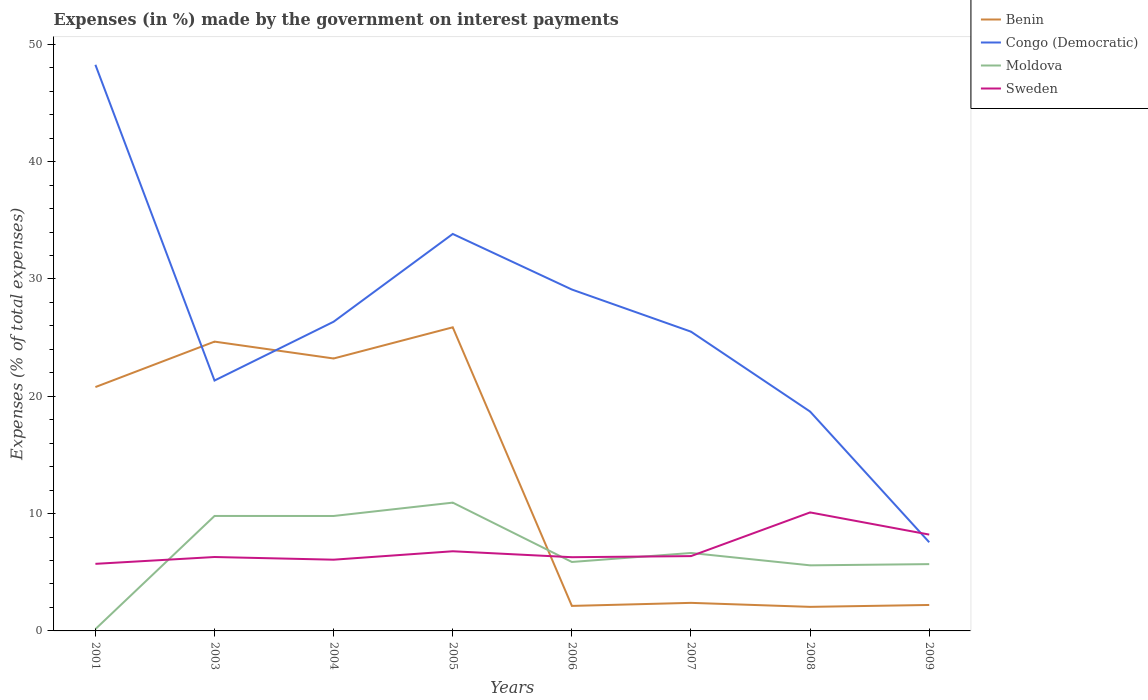How many different coloured lines are there?
Ensure brevity in your answer.  4. Does the line corresponding to Benin intersect with the line corresponding to Sweden?
Provide a short and direct response. Yes. Across all years, what is the maximum percentage of expenses made by the government on interest payments in Benin?
Provide a succinct answer. 2.05. In which year was the percentage of expenses made by the government on interest payments in Congo (Democratic) maximum?
Give a very brief answer. 2009. What is the total percentage of expenses made by the government on interest payments in Moldova in the graph?
Provide a short and direct response. 5.06. What is the difference between the highest and the second highest percentage of expenses made by the government on interest payments in Benin?
Offer a terse response. 23.83. What is the difference between the highest and the lowest percentage of expenses made by the government on interest payments in Moldova?
Ensure brevity in your answer.  3. Is the percentage of expenses made by the government on interest payments in Benin strictly greater than the percentage of expenses made by the government on interest payments in Congo (Democratic) over the years?
Offer a very short reply. No. What is the difference between two consecutive major ticks on the Y-axis?
Offer a terse response. 10. Where does the legend appear in the graph?
Offer a terse response. Top right. What is the title of the graph?
Offer a very short reply. Expenses (in %) made by the government on interest payments. Does "Guyana" appear as one of the legend labels in the graph?
Your answer should be very brief. No. What is the label or title of the X-axis?
Give a very brief answer. Years. What is the label or title of the Y-axis?
Your answer should be very brief. Expenses (% of total expenses). What is the Expenses (% of total expenses) in Benin in 2001?
Ensure brevity in your answer.  20.79. What is the Expenses (% of total expenses) in Congo (Democratic) in 2001?
Offer a terse response. 48.26. What is the Expenses (% of total expenses) in Moldova in 2001?
Your answer should be very brief. 0.16. What is the Expenses (% of total expenses) in Sweden in 2001?
Your answer should be compact. 5.72. What is the Expenses (% of total expenses) in Benin in 2003?
Offer a very short reply. 24.66. What is the Expenses (% of total expenses) in Congo (Democratic) in 2003?
Ensure brevity in your answer.  21.34. What is the Expenses (% of total expenses) of Moldova in 2003?
Your answer should be very brief. 9.8. What is the Expenses (% of total expenses) in Sweden in 2003?
Offer a very short reply. 6.3. What is the Expenses (% of total expenses) of Benin in 2004?
Ensure brevity in your answer.  23.22. What is the Expenses (% of total expenses) in Congo (Democratic) in 2004?
Ensure brevity in your answer.  26.36. What is the Expenses (% of total expenses) in Moldova in 2004?
Provide a short and direct response. 9.8. What is the Expenses (% of total expenses) in Sweden in 2004?
Your response must be concise. 6.07. What is the Expenses (% of total expenses) of Benin in 2005?
Make the answer very short. 25.88. What is the Expenses (% of total expenses) of Congo (Democratic) in 2005?
Your response must be concise. 33.84. What is the Expenses (% of total expenses) of Moldova in 2005?
Provide a short and direct response. 10.94. What is the Expenses (% of total expenses) in Sweden in 2005?
Your answer should be compact. 6.79. What is the Expenses (% of total expenses) in Benin in 2006?
Keep it short and to the point. 2.13. What is the Expenses (% of total expenses) of Congo (Democratic) in 2006?
Provide a short and direct response. 29.1. What is the Expenses (% of total expenses) of Moldova in 2006?
Make the answer very short. 5.88. What is the Expenses (% of total expenses) of Sweden in 2006?
Offer a terse response. 6.28. What is the Expenses (% of total expenses) of Benin in 2007?
Ensure brevity in your answer.  2.39. What is the Expenses (% of total expenses) of Congo (Democratic) in 2007?
Give a very brief answer. 25.51. What is the Expenses (% of total expenses) of Moldova in 2007?
Offer a very short reply. 6.64. What is the Expenses (% of total expenses) of Sweden in 2007?
Offer a terse response. 6.38. What is the Expenses (% of total expenses) in Benin in 2008?
Give a very brief answer. 2.05. What is the Expenses (% of total expenses) in Congo (Democratic) in 2008?
Provide a succinct answer. 18.7. What is the Expenses (% of total expenses) in Moldova in 2008?
Ensure brevity in your answer.  5.59. What is the Expenses (% of total expenses) of Sweden in 2008?
Offer a very short reply. 10.1. What is the Expenses (% of total expenses) of Benin in 2009?
Your response must be concise. 2.21. What is the Expenses (% of total expenses) in Congo (Democratic) in 2009?
Offer a terse response. 7.56. What is the Expenses (% of total expenses) of Moldova in 2009?
Offer a very short reply. 5.69. What is the Expenses (% of total expenses) of Sweden in 2009?
Provide a succinct answer. 8.21. Across all years, what is the maximum Expenses (% of total expenses) of Benin?
Your answer should be very brief. 25.88. Across all years, what is the maximum Expenses (% of total expenses) of Congo (Democratic)?
Provide a succinct answer. 48.26. Across all years, what is the maximum Expenses (% of total expenses) of Moldova?
Make the answer very short. 10.94. Across all years, what is the maximum Expenses (% of total expenses) in Sweden?
Keep it short and to the point. 10.1. Across all years, what is the minimum Expenses (% of total expenses) in Benin?
Make the answer very short. 2.05. Across all years, what is the minimum Expenses (% of total expenses) in Congo (Democratic)?
Your answer should be compact. 7.56. Across all years, what is the minimum Expenses (% of total expenses) in Moldova?
Keep it short and to the point. 0.16. Across all years, what is the minimum Expenses (% of total expenses) in Sweden?
Your answer should be compact. 5.72. What is the total Expenses (% of total expenses) of Benin in the graph?
Provide a succinct answer. 103.34. What is the total Expenses (% of total expenses) in Congo (Democratic) in the graph?
Your answer should be very brief. 210.66. What is the total Expenses (% of total expenses) of Moldova in the graph?
Provide a succinct answer. 54.49. What is the total Expenses (% of total expenses) of Sweden in the graph?
Your response must be concise. 55.85. What is the difference between the Expenses (% of total expenses) in Benin in 2001 and that in 2003?
Ensure brevity in your answer.  -3.87. What is the difference between the Expenses (% of total expenses) of Congo (Democratic) in 2001 and that in 2003?
Your answer should be very brief. 26.91. What is the difference between the Expenses (% of total expenses) of Moldova in 2001 and that in 2003?
Provide a short and direct response. -9.64. What is the difference between the Expenses (% of total expenses) of Sweden in 2001 and that in 2003?
Make the answer very short. -0.58. What is the difference between the Expenses (% of total expenses) in Benin in 2001 and that in 2004?
Ensure brevity in your answer.  -2.44. What is the difference between the Expenses (% of total expenses) in Congo (Democratic) in 2001 and that in 2004?
Make the answer very short. 21.9. What is the difference between the Expenses (% of total expenses) of Moldova in 2001 and that in 2004?
Offer a very short reply. -9.64. What is the difference between the Expenses (% of total expenses) in Sweden in 2001 and that in 2004?
Your response must be concise. -0.35. What is the difference between the Expenses (% of total expenses) of Benin in 2001 and that in 2005?
Your response must be concise. -5.09. What is the difference between the Expenses (% of total expenses) of Congo (Democratic) in 2001 and that in 2005?
Your answer should be very brief. 14.42. What is the difference between the Expenses (% of total expenses) in Moldova in 2001 and that in 2005?
Provide a succinct answer. -10.78. What is the difference between the Expenses (% of total expenses) in Sweden in 2001 and that in 2005?
Give a very brief answer. -1.07. What is the difference between the Expenses (% of total expenses) in Benin in 2001 and that in 2006?
Ensure brevity in your answer.  18.65. What is the difference between the Expenses (% of total expenses) in Congo (Democratic) in 2001 and that in 2006?
Your answer should be compact. 19.16. What is the difference between the Expenses (% of total expenses) in Moldova in 2001 and that in 2006?
Provide a short and direct response. -5.72. What is the difference between the Expenses (% of total expenses) of Sweden in 2001 and that in 2006?
Offer a very short reply. -0.57. What is the difference between the Expenses (% of total expenses) of Benin in 2001 and that in 2007?
Keep it short and to the point. 18.4. What is the difference between the Expenses (% of total expenses) in Congo (Democratic) in 2001 and that in 2007?
Make the answer very short. 22.75. What is the difference between the Expenses (% of total expenses) of Moldova in 2001 and that in 2007?
Provide a short and direct response. -6.49. What is the difference between the Expenses (% of total expenses) of Sweden in 2001 and that in 2007?
Your response must be concise. -0.66. What is the difference between the Expenses (% of total expenses) in Benin in 2001 and that in 2008?
Your response must be concise. 18.74. What is the difference between the Expenses (% of total expenses) in Congo (Democratic) in 2001 and that in 2008?
Keep it short and to the point. 29.56. What is the difference between the Expenses (% of total expenses) in Moldova in 2001 and that in 2008?
Keep it short and to the point. -5.43. What is the difference between the Expenses (% of total expenses) of Sweden in 2001 and that in 2008?
Your answer should be compact. -4.38. What is the difference between the Expenses (% of total expenses) of Benin in 2001 and that in 2009?
Your answer should be compact. 18.57. What is the difference between the Expenses (% of total expenses) of Congo (Democratic) in 2001 and that in 2009?
Your response must be concise. 40.7. What is the difference between the Expenses (% of total expenses) in Moldova in 2001 and that in 2009?
Your answer should be compact. -5.54. What is the difference between the Expenses (% of total expenses) of Sweden in 2001 and that in 2009?
Offer a terse response. -2.49. What is the difference between the Expenses (% of total expenses) of Benin in 2003 and that in 2004?
Give a very brief answer. 1.44. What is the difference between the Expenses (% of total expenses) in Congo (Democratic) in 2003 and that in 2004?
Provide a short and direct response. -5.01. What is the difference between the Expenses (% of total expenses) of Moldova in 2003 and that in 2004?
Your response must be concise. 0. What is the difference between the Expenses (% of total expenses) in Sweden in 2003 and that in 2004?
Your answer should be very brief. 0.23. What is the difference between the Expenses (% of total expenses) of Benin in 2003 and that in 2005?
Make the answer very short. -1.22. What is the difference between the Expenses (% of total expenses) of Congo (Democratic) in 2003 and that in 2005?
Provide a succinct answer. -12.5. What is the difference between the Expenses (% of total expenses) of Moldova in 2003 and that in 2005?
Your answer should be compact. -1.14. What is the difference between the Expenses (% of total expenses) of Sweden in 2003 and that in 2005?
Keep it short and to the point. -0.49. What is the difference between the Expenses (% of total expenses) of Benin in 2003 and that in 2006?
Ensure brevity in your answer.  22.53. What is the difference between the Expenses (% of total expenses) of Congo (Democratic) in 2003 and that in 2006?
Offer a terse response. -7.76. What is the difference between the Expenses (% of total expenses) in Moldova in 2003 and that in 2006?
Your response must be concise. 3.92. What is the difference between the Expenses (% of total expenses) in Sweden in 2003 and that in 2006?
Give a very brief answer. 0.02. What is the difference between the Expenses (% of total expenses) in Benin in 2003 and that in 2007?
Your response must be concise. 22.27. What is the difference between the Expenses (% of total expenses) in Congo (Democratic) in 2003 and that in 2007?
Provide a short and direct response. -4.17. What is the difference between the Expenses (% of total expenses) of Moldova in 2003 and that in 2007?
Provide a succinct answer. 3.16. What is the difference between the Expenses (% of total expenses) in Sweden in 2003 and that in 2007?
Offer a very short reply. -0.08. What is the difference between the Expenses (% of total expenses) in Benin in 2003 and that in 2008?
Give a very brief answer. 22.61. What is the difference between the Expenses (% of total expenses) in Congo (Democratic) in 2003 and that in 2008?
Give a very brief answer. 2.65. What is the difference between the Expenses (% of total expenses) in Moldova in 2003 and that in 2008?
Keep it short and to the point. 4.21. What is the difference between the Expenses (% of total expenses) of Sweden in 2003 and that in 2008?
Offer a very short reply. -3.8. What is the difference between the Expenses (% of total expenses) of Benin in 2003 and that in 2009?
Ensure brevity in your answer.  22.45. What is the difference between the Expenses (% of total expenses) in Congo (Democratic) in 2003 and that in 2009?
Make the answer very short. 13.79. What is the difference between the Expenses (% of total expenses) in Moldova in 2003 and that in 2009?
Keep it short and to the point. 4.11. What is the difference between the Expenses (% of total expenses) in Sweden in 2003 and that in 2009?
Your answer should be very brief. -1.91. What is the difference between the Expenses (% of total expenses) in Benin in 2004 and that in 2005?
Offer a very short reply. -2.66. What is the difference between the Expenses (% of total expenses) of Congo (Democratic) in 2004 and that in 2005?
Make the answer very short. -7.48. What is the difference between the Expenses (% of total expenses) in Moldova in 2004 and that in 2005?
Provide a short and direct response. -1.14. What is the difference between the Expenses (% of total expenses) in Sweden in 2004 and that in 2005?
Your response must be concise. -0.72. What is the difference between the Expenses (% of total expenses) of Benin in 2004 and that in 2006?
Offer a terse response. 21.09. What is the difference between the Expenses (% of total expenses) in Congo (Democratic) in 2004 and that in 2006?
Provide a succinct answer. -2.74. What is the difference between the Expenses (% of total expenses) of Moldova in 2004 and that in 2006?
Provide a short and direct response. 3.92. What is the difference between the Expenses (% of total expenses) of Sweden in 2004 and that in 2006?
Your answer should be very brief. -0.21. What is the difference between the Expenses (% of total expenses) in Benin in 2004 and that in 2007?
Offer a terse response. 20.83. What is the difference between the Expenses (% of total expenses) in Congo (Democratic) in 2004 and that in 2007?
Provide a short and direct response. 0.85. What is the difference between the Expenses (% of total expenses) of Moldova in 2004 and that in 2007?
Give a very brief answer. 3.15. What is the difference between the Expenses (% of total expenses) of Sweden in 2004 and that in 2007?
Keep it short and to the point. -0.31. What is the difference between the Expenses (% of total expenses) in Benin in 2004 and that in 2008?
Provide a succinct answer. 21.17. What is the difference between the Expenses (% of total expenses) in Congo (Democratic) in 2004 and that in 2008?
Offer a terse response. 7.66. What is the difference between the Expenses (% of total expenses) in Moldova in 2004 and that in 2008?
Offer a terse response. 4.21. What is the difference between the Expenses (% of total expenses) of Sweden in 2004 and that in 2008?
Ensure brevity in your answer.  -4.03. What is the difference between the Expenses (% of total expenses) of Benin in 2004 and that in 2009?
Give a very brief answer. 21.01. What is the difference between the Expenses (% of total expenses) in Congo (Democratic) in 2004 and that in 2009?
Provide a short and direct response. 18.8. What is the difference between the Expenses (% of total expenses) of Moldova in 2004 and that in 2009?
Offer a terse response. 4.1. What is the difference between the Expenses (% of total expenses) of Sweden in 2004 and that in 2009?
Offer a terse response. -2.14. What is the difference between the Expenses (% of total expenses) in Benin in 2005 and that in 2006?
Your response must be concise. 23.75. What is the difference between the Expenses (% of total expenses) of Congo (Democratic) in 2005 and that in 2006?
Keep it short and to the point. 4.74. What is the difference between the Expenses (% of total expenses) of Moldova in 2005 and that in 2006?
Your response must be concise. 5.06. What is the difference between the Expenses (% of total expenses) of Sweden in 2005 and that in 2006?
Provide a short and direct response. 0.51. What is the difference between the Expenses (% of total expenses) in Benin in 2005 and that in 2007?
Offer a terse response. 23.49. What is the difference between the Expenses (% of total expenses) in Congo (Democratic) in 2005 and that in 2007?
Your answer should be compact. 8.33. What is the difference between the Expenses (% of total expenses) in Moldova in 2005 and that in 2007?
Provide a short and direct response. 4.29. What is the difference between the Expenses (% of total expenses) of Sweden in 2005 and that in 2007?
Ensure brevity in your answer.  0.41. What is the difference between the Expenses (% of total expenses) of Benin in 2005 and that in 2008?
Provide a succinct answer. 23.83. What is the difference between the Expenses (% of total expenses) in Congo (Democratic) in 2005 and that in 2008?
Give a very brief answer. 15.14. What is the difference between the Expenses (% of total expenses) in Moldova in 2005 and that in 2008?
Your answer should be compact. 5.35. What is the difference between the Expenses (% of total expenses) in Sweden in 2005 and that in 2008?
Provide a short and direct response. -3.31. What is the difference between the Expenses (% of total expenses) of Benin in 2005 and that in 2009?
Ensure brevity in your answer.  23.67. What is the difference between the Expenses (% of total expenses) in Congo (Democratic) in 2005 and that in 2009?
Offer a very short reply. 26.28. What is the difference between the Expenses (% of total expenses) in Moldova in 2005 and that in 2009?
Give a very brief answer. 5.24. What is the difference between the Expenses (% of total expenses) of Sweden in 2005 and that in 2009?
Offer a terse response. -1.42. What is the difference between the Expenses (% of total expenses) in Benin in 2006 and that in 2007?
Ensure brevity in your answer.  -0.26. What is the difference between the Expenses (% of total expenses) in Congo (Democratic) in 2006 and that in 2007?
Give a very brief answer. 3.59. What is the difference between the Expenses (% of total expenses) of Moldova in 2006 and that in 2007?
Your answer should be compact. -0.77. What is the difference between the Expenses (% of total expenses) in Sweden in 2006 and that in 2007?
Offer a very short reply. -0.09. What is the difference between the Expenses (% of total expenses) of Benin in 2006 and that in 2008?
Ensure brevity in your answer.  0.08. What is the difference between the Expenses (% of total expenses) of Congo (Democratic) in 2006 and that in 2008?
Keep it short and to the point. 10.4. What is the difference between the Expenses (% of total expenses) of Moldova in 2006 and that in 2008?
Provide a succinct answer. 0.29. What is the difference between the Expenses (% of total expenses) in Sweden in 2006 and that in 2008?
Your answer should be very brief. -3.82. What is the difference between the Expenses (% of total expenses) in Benin in 2006 and that in 2009?
Provide a succinct answer. -0.08. What is the difference between the Expenses (% of total expenses) in Congo (Democratic) in 2006 and that in 2009?
Offer a terse response. 21.54. What is the difference between the Expenses (% of total expenses) in Moldova in 2006 and that in 2009?
Give a very brief answer. 0.18. What is the difference between the Expenses (% of total expenses) of Sweden in 2006 and that in 2009?
Provide a succinct answer. -1.93. What is the difference between the Expenses (% of total expenses) in Benin in 2007 and that in 2008?
Keep it short and to the point. 0.34. What is the difference between the Expenses (% of total expenses) of Congo (Democratic) in 2007 and that in 2008?
Provide a succinct answer. 6.81. What is the difference between the Expenses (% of total expenses) of Moldova in 2007 and that in 2008?
Your answer should be very brief. 1.05. What is the difference between the Expenses (% of total expenses) in Sweden in 2007 and that in 2008?
Your answer should be very brief. -3.72. What is the difference between the Expenses (% of total expenses) in Benin in 2007 and that in 2009?
Make the answer very short. 0.18. What is the difference between the Expenses (% of total expenses) of Congo (Democratic) in 2007 and that in 2009?
Offer a terse response. 17.95. What is the difference between the Expenses (% of total expenses) of Moldova in 2007 and that in 2009?
Provide a succinct answer. 0.95. What is the difference between the Expenses (% of total expenses) of Sweden in 2007 and that in 2009?
Offer a very short reply. -1.83. What is the difference between the Expenses (% of total expenses) in Benin in 2008 and that in 2009?
Give a very brief answer. -0.16. What is the difference between the Expenses (% of total expenses) of Congo (Democratic) in 2008 and that in 2009?
Ensure brevity in your answer.  11.14. What is the difference between the Expenses (% of total expenses) in Moldova in 2008 and that in 2009?
Make the answer very short. -0.1. What is the difference between the Expenses (% of total expenses) in Sweden in 2008 and that in 2009?
Provide a succinct answer. 1.89. What is the difference between the Expenses (% of total expenses) of Benin in 2001 and the Expenses (% of total expenses) of Congo (Democratic) in 2003?
Make the answer very short. -0.56. What is the difference between the Expenses (% of total expenses) in Benin in 2001 and the Expenses (% of total expenses) in Moldova in 2003?
Your answer should be very brief. 10.99. What is the difference between the Expenses (% of total expenses) of Benin in 2001 and the Expenses (% of total expenses) of Sweden in 2003?
Offer a very short reply. 14.49. What is the difference between the Expenses (% of total expenses) in Congo (Democratic) in 2001 and the Expenses (% of total expenses) in Moldova in 2003?
Ensure brevity in your answer.  38.46. What is the difference between the Expenses (% of total expenses) of Congo (Democratic) in 2001 and the Expenses (% of total expenses) of Sweden in 2003?
Make the answer very short. 41.96. What is the difference between the Expenses (% of total expenses) of Moldova in 2001 and the Expenses (% of total expenses) of Sweden in 2003?
Your answer should be very brief. -6.14. What is the difference between the Expenses (% of total expenses) in Benin in 2001 and the Expenses (% of total expenses) in Congo (Democratic) in 2004?
Offer a terse response. -5.57. What is the difference between the Expenses (% of total expenses) in Benin in 2001 and the Expenses (% of total expenses) in Moldova in 2004?
Offer a very short reply. 10.99. What is the difference between the Expenses (% of total expenses) in Benin in 2001 and the Expenses (% of total expenses) in Sweden in 2004?
Your answer should be compact. 14.72. What is the difference between the Expenses (% of total expenses) in Congo (Democratic) in 2001 and the Expenses (% of total expenses) in Moldova in 2004?
Your answer should be very brief. 38.46. What is the difference between the Expenses (% of total expenses) in Congo (Democratic) in 2001 and the Expenses (% of total expenses) in Sweden in 2004?
Provide a succinct answer. 42.19. What is the difference between the Expenses (% of total expenses) in Moldova in 2001 and the Expenses (% of total expenses) in Sweden in 2004?
Your answer should be very brief. -5.92. What is the difference between the Expenses (% of total expenses) of Benin in 2001 and the Expenses (% of total expenses) of Congo (Democratic) in 2005?
Give a very brief answer. -13.05. What is the difference between the Expenses (% of total expenses) in Benin in 2001 and the Expenses (% of total expenses) in Moldova in 2005?
Provide a short and direct response. 9.85. What is the difference between the Expenses (% of total expenses) of Benin in 2001 and the Expenses (% of total expenses) of Sweden in 2005?
Make the answer very short. 14. What is the difference between the Expenses (% of total expenses) in Congo (Democratic) in 2001 and the Expenses (% of total expenses) in Moldova in 2005?
Provide a short and direct response. 37.32. What is the difference between the Expenses (% of total expenses) of Congo (Democratic) in 2001 and the Expenses (% of total expenses) of Sweden in 2005?
Make the answer very short. 41.47. What is the difference between the Expenses (% of total expenses) of Moldova in 2001 and the Expenses (% of total expenses) of Sweden in 2005?
Offer a terse response. -6.63. What is the difference between the Expenses (% of total expenses) of Benin in 2001 and the Expenses (% of total expenses) of Congo (Democratic) in 2006?
Provide a short and direct response. -8.31. What is the difference between the Expenses (% of total expenses) of Benin in 2001 and the Expenses (% of total expenses) of Moldova in 2006?
Keep it short and to the point. 14.91. What is the difference between the Expenses (% of total expenses) of Benin in 2001 and the Expenses (% of total expenses) of Sweden in 2006?
Provide a succinct answer. 14.5. What is the difference between the Expenses (% of total expenses) of Congo (Democratic) in 2001 and the Expenses (% of total expenses) of Moldova in 2006?
Your response must be concise. 42.38. What is the difference between the Expenses (% of total expenses) in Congo (Democratic) in 2001 and the Expenses (% of total expenses) in Sweden in 2006?
Your response must be concise. 41.97. What is the difference between the Expenses (% of total expenses) of Moldova in 2001 and the Expenses (% of total expenses) of Sweden in 2006?
Ensure brevity in your answer.  -6.13. What is the difference between the Expenses (% of total expenses) of Benin in 2001 and the Expenses (% of total expenses) of Congo (Democratic) in 2007?
Offer a very short reply. -4.72. What is the difference between the Expenses (% of total expenses) in Benin in 2001 and the Expenses (% of total expenses) in Moldova in 2007?
Your answer should be compact. 14.14. What is the difference between the Expenses (% of total expenses) in Benin in 2001 and the Expenses (% of total expenses) in Sweden in 2007?
Your answer should be compact. 14.41. What is the difference between the Expenses (% of total expenses) of Congo (Democratic) in 2001 and the Expenses (% of total expenses) of Moldova in 2007?
Provide a short and direct response. 41.61. What is the difference between the Expenses (% of total expenses) in Congo (Democratic) in 2001 and the Expenses (% of total expenses) in Sweden in 2007?
Offer a terse response. 41.88. What is the difference between the Expenses (% of total expenses) in Moldova in 2001 and the Expenses (% of total expenses) in Sweden in 2007?
Give a very brief answer. -6.22. What is the difference between the Expenses (% of total expenses) in Benin in 2001 and the Expenses (% of total expenses) in Congo (Democratic) in 2008?
Keep it short and to the point. 2.09. What is the difference between the Expenses (% of total expenses) of Benin in 2001 and the Expenses (% of total expenses) of Moldova in 2008?
Ensure brevity in your answer.  15.2. What is the difference between the Expenses (% of total expenses) in Benin in 2001 and the Expenses (% of total expenses) in Sweden in 2008?
Provide a succinct answer. 10.69. What is the difference between the Expenses (% of total expenses) of Congo (Democratic) in 2001 and the Expenses (% of total expenses) of Moldova in 2008?
Give a very brief answer. 42.67. What is the difference between the Expenses (% of total expenses) in Congo (Democratic) in 2001 and the Expenses (% of total expenses) in Sweden in 2008?
Offer a terse response. 38.16. What is the difference between the Expenses (% of total expenses) in Moldova in 2001 and the Expenses (% of total expenses) in Sweden in 2008?
Offer a very short reply. -9.95. What is the difference between the Expenses (% of total expenses) in Benin in 2001 and the Expenses (% of total expenses) in Congo (Democratic) in 2009?
Offer a terse response. 13.23. What is the difference between the Expenses (% of total expenses) in Benin in 2001 and the Expenses (% of total expenses) in Moldova in 2009?
Provide a succinct answer. 15.09. What is the difference between the Expenses (% of total expenses) of Benin in 2001 and the Expenses (% of total expenses) of Sweden in 2009?
Ensure brevity in your answer.  12.58. What is the difference between the Expenses (% of total expenses) of Congo (Democratic) in 2001 and the Expenses (% of total expenses) of Moldova in 2009?
Your answer should be compact. 42.56. What is the difference between the Expenses (% of total expenses) of Congo (Democratic) in 2001 and the Expenses (% of total expenses) of Sweden in 2009?
Make the answer very short. 40.05. What is the difference between the Expenses (% of total expenses) in Moldova in 2001 and the Expenses (% of total expenses) in Sweden in 2009?
Your answer should be compact. -8.06. What is the difference between the Expenses (% of total expenses) in Benin in 2003 and the Expenses (% of total expenses) in Congo (Democratic) in 2004?
Make the answer very short. -1.7. What is the difference between the Expenses (% of total expenses) of Benin in 2003 and the Expenses (% of total expenses) of Moldova in 2004?
Your answer should be very brief. 14.86. What is the difference between the Expenses (% of total expenses) of Benin in 2003 and the Expenses (% of total expenses) of Sweden in 2004?
Make the answer very short. 18.59. What is the difference between the Expenses (% of total expenses) of Congo (Democratic) in 2003 and the Expenses (% of total expenses) of Moldova in 2004?
Ensure brevity in your answer.  11.54. What is the difference between the Expenses (% of total expenses) in Congo (Democratic) in 2003 and the Expenses (% of total expenses) in Sweden in 2004?
Keep it short and to the point. 15.27. What is the difference between the Expenses (% of total expenses) in Moldova in 2003 and the Expenses (% of total expenses) in Sweden in 2004?
Provide a short and direct response. 3.73. What is the difference between the Expenses (% of total expenses) in Benin in 2003 and the Expenses (% of total expenses) in Congo (Democratic) in 2005?
Ensure brevity in your answer.  -9.18. What is the difference between the Expenses (% of total expenses) of Benin in 2003 and the Expenses (% of total expenses) of Moldova in 2005?
Your answer should be compact. 13.72. What is the difference between the Expenses (% of total expenses) of Benin in 2003 and the Expenses (% of total expenses) of Sweden in 2005?
Your answer should be very brief. 17.87. What is the difference between the Expenses (% of total expenses) of Congo (Democratic) in 2003 and the Expenses (% of total expenses) of Moldova in 2005?
Your answer should be very brief. 10.41. What is the difference between the Expenses (% of total expenses) in Congo (Democratic) in 2003 and the Expenses (% of total expenses) in Sweden in 2005?
Offer a terse response. 14.55. What is the difference between the Expenses (% of total expenses) of Moldova in 2003 and the Expenses (% of total expenses) of Sweden in 2005?
Make the answer very short. 3.01. What is the difference between the Expenses (% of total expenses) of Benin in 2003 and the Expenses (% of total expenses) of Congo (Democratic) in 2006?
Give a very brief answer. -4.44. What is the difference between the Expenses (% of total expenses) of Benin in 2003 and the Expenses (% of total expenses) of Moldova in 2006?
Your answer should be very brief. 18.78. What is the difference between the Expenses (% of total expenses) of Benin in 2003 and the Expenses (% of total expenses) of Sweden in 2006?
Offer a terse response. 18.38. What is the difference between the Expenses (% of total expenses) of Congo (Democratic) in 2003 and the Expenses (% of total expenses) of Moldova in 2006?
Keep it short and to the point. 15.47. What is the difference between the Expenses (% of total expenses) of Congo (Democratic) in 2003 and the Expenses (% of total expenses) of Sweden in 2006?
Provide a succinct answer. 15.06. What is the difference between the Expenses (% of total expenses) in Moldova in 2003 and the Expenses (% of total expenses) in Sweden in 2006?
Ensure brevity in your answer.  3.52. What is the difference between the Expenses (% of total expenses) in Benin in 2003 and the Expenses (% of total expenses) in Congo (Democratic) in 2007?
Keep it short and to the point. -0.85. What is the difference between the Expenses (% of total expenses) in Benin in 2003 and the Expenses (% of total expenses) in Moldova in 2007?
Give a very brief answer. 18.02. What is the difference between the Expenses (% of total expenses) of Benin in 2003 and the Expenses (% of total expenses) of Sweden in 2007?
Ensure brevity in your answer.  18.28. What is the difference between the Expenses (% of total expenses) of Congo (Democratic) in 2003 and the Expenses (% of total expenses) of Moldova in 2007?
Provide a succinct answer. 14.7. What is the difference between the Expenses (% of total expenses) of Congo (Democratic) in 2003 and the Expenses (% of total expenses) of Sweden in 2007?
Ensure brevity in your answer.  14.97. What is the difference between the Expenses (% of total expenses) of Moldova in 2003 and the Expenses (% of total expenses) of Sweden in 2007?
Your answer should be very brief. 3.42. What is the difference between the Expenses (% of total expenses) of Benin in 2003 and the Expenses (% of total expenses) of Congo (Democratic) in 2008?
Provide a succinct answer. 5.96. What is the difference between the Expenses (% of total expenses) of Benin in 2003 and the Expenses (% of total expenses) of Moldova in 2008?
Your answer should be very brief. 19.07. What is the difference between the Expenses (% of total expenses) of Benin in 2003 and the Expenses (% of total expenses) of Sweden in 2008?
Provide a short and direct response. 14.56. What is the difference between the Expenses (% of total expenses) in Congo (Democratic) in 2003 and the Expenses (% of total expenses) in Moldova in 2008?
Your answer should be very brief. 15.75. What is the difference between the Expenses (% of total expenses) in Congo (Democratic) in 2003 and the Expenses (% of total expenses) in Sweden in 2008?
Your answer should be very brief. 11.24. What is the difference between the Expenses (% of total expenses) in Moldova in 2003 and the Expenses (% of total expenses) in Sweden in 2008?
Offer a terse response. -0.3. What is the difference between the Expenses (% of total expenses) in Benin in 2003 and the Expenses (% of total expenses) in Congo (Democratic) in 2009?
Your answer should be very brief. 17.1. What is the difference between the Expenses (% of total expenses) in Benin in 2003 and the Expenses (% of total expenses) in Moldova in 2009?
Offer a very short reply. 18.97. What is the difference between the Expenses (% of total expenses) in Benin in 2003 and the Expenses (% of total expenses) in Sweden in 2009?
Make the answer very short. 16.45. What is the difference between the Expenses (% of total expenses) in Congo (Democratic) in 2003 and the Expenses (% of total expenses) in Moldova in 2009?
Your response must be concise. 15.65. What is the difference between the Expenses (% of total expenses) of Congo (Democratic) in 2003 and the Expenses (% of total expenses) of Sweden in 2009?
Keep it short and to the point. 13.13. What is the difference between the Expenses (% of total expenses) in Moldova in 2003 and the Expenses (% of total expenses) in Sweden in 2009?
Make the answer very short. 1.59. What is the difference between the Expenses (% of total expenses) in Benin in 2004 and the Expenses (% of total expenses) in Congo (Democratic) in 2005?
Your answer should be very brief. -10.62. What is the difference between the Expenses (% of total expenses) of Benin in 2004 and the Expenses (% of total expenses) of Moldova in 2005?
Your answer should be very brief. 12.29. What is the difference between the Expenses (% of total expenses) of Benin in 2004 and the Expenses (% of total expenses) of Sweden in 2005?
Offer a very short reply. 16.43. What is the difference between the Expenses (% of total expenses) of Congo (Democratic) in 2004 and the Expenses (% of total expenses) of Moldova in 2005?
Offer a very short reply. 15.42. What is the difference between the Expenses (% of total expenses) of Congo (Democratic) in 2004 and the Expenses (% of total expenses) of Sweden in 2005?
Provide a succinct answer. 19.57. What is the difference between the Expenses (% of total expenses) in Moldova in 2004 and the Expenses (% of total expenses) in Sweden in 2005?
Ensure brevity in your answer.  3.01. What is the difference between the Expenses (% of total expenses) of Benin in 2004 and the Expenses (% of total expenses) of Congo (Democratic) in 2006?
Your answer should be compact. -5.88. What is the difference between the Expenses (% of total expenses) in Benin in 2004 and the Expenses (% of total expenses) in Moldova in 2006?
Provide a succinct answer. 17.34. What is the difference between the Expenses (% of total expenses) of Benin in 2004 and the Expenses (% of total expenses) of Sweden in 2006?
Offer a terse response. 16.94. What is the difference between the Expenses (% of total expenses) in Congo (Democratic) in 2004 and the Expenses (% of total expenses) in Moldova in 2006?
Provide a short and direct response. 20.48. What is the difference between the Expenses (% of total expenses) of Congo (Democratic) in 2004 and the Expenses (% of total expenses) of Sweden in 2006?
Offer a very short reply. 20.07. What is the difference between the Expenses (% of total expenses) of Moldova in 2004 and the Expenses (% of total expenses) of Sweden in 2006?
Make the answer very short. 3.51. What is the difference between the Expenses (% of total expenses) in Benin in 2004 and the Expenses (% of total expenses) in Congo (Democratic) in 2007?
Offer a very short reply. -2.29. What is the difference between the Expenses (% of total expenses) in Benin in 2004 and the Expenses (% of total expenses) in Moldova in 2007?
Your answer should be very brief. 16.58. What is the difference between the Expenses (% of total expenses) of Benin in 2004 and the Expenses (% of total expenses) of Sweden in 2007?
Your answer should be very brief. 16.85. What is the difference between the Expenses (% of total expenses) of Congo (Democratic) in 2004 and the Expenses (% of total expenses) of Moldova in 2007?
Make the answer very short. 19.71. What is the difference between the Expenses (% of total expenses) of Congo (Democratic) in 2004 and the Expenses (% of total expenses) of Sweden in 2007?
Ensure brevity in your answer.  19.98. What is the difference between the Expenses (% of total expenses) in Moldova in 2004 and the Expenses (% of total expenses) in Sweden in 2007?
Offer a terse response. 3.42. What is the difference between the Expenses (% of total expenses) of Benin in 2004 and the Expenses (% of total expenses) of Congo (Democratic) in 2008?
Your response must be concise. 4.53. What is the difference between the Expenses (% of total expenses) in Benin in 2004 and the Expenses (% of total expenses) in Moldova in 2008?
Keep it short and to the point. 17.63. What is the difference between the Expenses (% of total expenses) of Benin in 2004 and the Expenses (% of total expenses) of Sweden in 2008?
Provide a short and direct response. 13.12. What is the difference between the Expenses (% of total expenses) in Congo (Democratic) in 2004 and the Expenses (% of total expenses) in Moldova in 2008?
Provide a short and direct response. 20.77. What is the difference between the Expenses (% of total expenses) in Congo (Democratic) in 2004 and the Expenses (% of total expenses) in Sweden in 2008?
Your answer should be very brief. 16.26. What is the difference between the Expenses (% of total expenses) in Moldova in 2004 and the Expenses (% of total expenses) in Sweden in 2008?
Your answer should be very brief. -0.3. What is the difference between the Expenses (% of total expenses) in Benin in 2004 and the Expenses (% of total expenses) in Congo (Democratic) in 2009?
Make the answer very short. 15.67. What is the difference between the Expenses (% of total expenses) of Benin in 2004 and the Expenses (% of total expenses) of Moldova in 2009?
Your answer should be very brief. 17.53. What is the difference between the Expenses (% of total expenses) in Benin in 2004 and the Expenses (% of total expenses) in Sweden in 2009?
Make the answer very short. 15.01. What is the difference between the Expenses (% of total expenses) of Congo (Democratic) in 2004 and the Expenses (% of total expenses) of Moldova in 2009?
Keep it short and to the point. 20.66. What is the difference between the Expenses (% of total expenses) in Congo (Democratic) in 2004 and the Expenses (% of total expenses) in Sweden in 2009?
Provide a short and direct response. 18.15. What is the difference between the Expenses (% of total expenses) in Moldova in 2004 and the Expenses (% of total expenses) in Sweden in 2009?
Your answer should be very brief. 1.59. What is the difference between the Expenses (% of total expenses) in Benin in 2005 and the Expenses (% of total expenses) in Congo (Democratic) in 2006?
Offer a very short reply. -3.22. What is the difference between the Expenses (% of total expenses) of Benin in 2005 and the Expenses (% of total expenses) of Moldova in 2006?
Provide a succinct answer. 20. What is the difference between the Expenses (% of total expenses) of Benin in 2005 and the Expenses (% of total expenses) of Sweden in 2006?
Your answer should be very brief. 19.6. What is the difference between the Expenses (% of total expenses) in Congo (Democratic) in 2005 and the Expenses (% of total expenses) in Moldova in 2006?
Keep it short and to the point. 27.96. What is the difference between the Expenses (% of total expenses) in Congo (Democratic) in 2005 and the Expenses (% of total expenses) in Sweden in 2006?
Provide a short and direct response. 27.55. What is the difference between the Expenses (% of total expenses) of Moldova in 2005 and the Expenses (% of total expenses) of Sweden in 2006?
Provide a succinct answer. 4.65. What is the difference between the Expenses (% of total expenses) in Benin in 2005 and the Expenses (% of total expenses) in Congo (Democratic) in 2007?
Provide a short and direct response. 0.37. What is the difference between the Expenses (% of total expenses) of Benin in 2005 and the Expenses (% of total expenses) of Moldova in 2007?
Your response must be concise. 19.24. What is the difference between the Expenses (% of total expenses) in Benin in 2005 and the Expenses (% of total expenses) in Sweden in 2007?
Your response must be concise. 19.5. What is the difference between the Expenses (% of total expenses) of Congo (Democratic) in 2005 and the Expenses (% of total expenses) of Moldova in 2007?
Ensure brevity in your answer.  27.19. What is the difference between the Expenses (% of total expenses) in Congo (Democratic) in 2005 and the Expenses (% of total expenses) in Sweden in 2007?
Make the answer very short. 27.46. What is the difference between the Expenses (% of total expenses) in Moldova in 2005 and the Expenses (% of total expenses) in Sweden in 2007?
Your answer should be compact. 4.56. What is the difference between the Expenses (% of total expenses) of Benin in 2005 and the Expenses (% of total expenses) of Congo (Democratic) in 2008?
Your answer should be very brief. 7.18. What is the difference between the Expenses (% of total expenses) in Benin in 2005 and the Expenses (% of total expenses) in Moldova in 2008?
Your response must be concise. 20.29. What is the difference between the Expenses (% of total expenses) in Benin in 2005 and the Expenses (% of total expenses) in Sweden in 2008?
Ensure brevity in your answer.  15.78. What is the difference between the Expenses (% of total expenses) of Congo (Democratic) in 2005 and the Expenses (% of total expenses) of Moldova in 2008?
Ensure brevity in your answer.  28.25. What is the difference between the Expenses (% of total expenses) of Congo (Democratic) in 2005 and the Expenses (% of total expenses) of Sweden in 2008?
Your response must be concise. 23.74. What is the difference between the Expenses (% of total expenses) of Moldova in 2005 and the Expenses (% of total expenses) of Sweden in 2008?
Keep it short and to the point. 0.84. What is the difference between the Expenses (% of total expenses) in Benin in 2005 and the Expenses (% of total expenses) in Congo (Democratic) in 2009?
Offer a terse response. 18.32. What is the difference between the Expenses (% of total expenses) of Benin in 2005 and the Expenses (% of total expenses) of Moldova in 2009?
Give a very brief answer. 20.19. What is the difference between the Expenses (% of total expenses) of Benin in 2005 and the Expenses (% of total expenses) of Sweden in 2009?
Your response must be concise. 17.67. What is the difference between the Expenses (% of total expenses) of Congo (Democratic) in 2005 and the Expenses (% of total expenses) of Moldova in 2009?
Keep it short and to the point. 28.14. What is the difference between the Expenses (% of total expenses) in Congo (Democratic) in 2005 and the Expenses (% of total expenses) in Sweden in 2009?
Provide a succinct answer. 25.63. What is the difference between the Expenses (% of total expenses) of Moldova in 2005 and the Expenses (% of total expenses) of Sweden in 2009?
Your answer should be very brief. 2.72. What is the difference between the Expenses (% of total expenses) in Benin in 2006 and the Expenses (% of total expenses) in Congo (Democratic) in 2007?
Your response must be concise. -23.38. What is the difference between the Expenses (% of total expenses) of Benin in 2006 and the Expenses (% of total expenses) of Moldova in 2007?
Provide a succinct answer. -4.51. What is the difference between the Expenses (% of total expenses) of Benin in 2006 and the Expenses (% of total expenses) of Sweden in 2007?
Provide a succinct answer. -4.24. What is the difference between the Expenses (% of total expenses) of Congo (Democratic) in 2006 and the Expenses (% of total expenses) of Moldova in 2007?
Keep it short and to the point. 22.46. What is the difference between the Expenses (% of total expenses) in Congo (Democratic) in 2006 and the Expenses (% of total expenses) in Sweden in 2007?
Your response must be concise. 22.72. What is the difference between the Expenses (% of total expenses) of Moldova in 2006 and the Expenses (% of total expenses) of Sweden in 2007?
Your answer should be compact. -0.5. What is the difference between the Expenses (% of total expenses) of Benin in 2006 and the Expenses (% of total expenses) of Congo (Democratic) in 2008?
Offer a very short reply. -16.56. What is the difference between the Expenses (% of total expenses) in Benin in 2006 and the Expenses (% of total expenses) in Moldova in 2008?
Offer a very short reply. -3.46. What is the difference between the Expenses (% of total expenses) of Benin in 2006 and the Expenses (% of total expenses) of Sweden in 2008?
Keep it short and to the point. -7.97. What is the difference between the Expenses (% of total expenses) in Congo (Democratic) in 2006 and the Expenses (% of total expenses) in Moldova in 2008?
Offer a terse response. 23.51. What is the difference between the Expenses (% of total expenses) in Congo (Democratic) in 2006 and the Expenses (% of total expenses) in Sweden in 2008?
Your response must be concise. 19. What is the difference between the Expenses (% of total expenses) of Moldova in 2006 and the Expenses (% of total expenses) of Sweden in 2008?
Provide a succinct answer. -4.22. What is the difference between the Expenses (% of total expenses) in Benin in 2006 and the Expenses (% of total expenses) in Congo (Democratic) in 2009?
Your response must be concise. -5.42. What is the difference between the Expenses (% of total expenses) of Benin in 2006 and the Expenses (% of total expenses) of Moldova in 2009?
Give a very brief answer. -3.56. What is the difference between the Expenses (% of total expenses) of Benin in 2006 and the Expenses (% of total expenses) of Sweden in 2009?
Your answer should be very brief. -6.08. What is the difference between the Expenses (% of total expenses) of Congo (Democratic) in 2006 and the Expenses (% of total expenses) of Moldova in 2009?
Give a very brief answer. 23.41. What is the difference between the Expenses (% of total expenses) of Congo (Democratic) in 2006 and the Expenses (% of total expenses) of Sweden in 2009?
Ensure brevity in your answer.  20.89. What is the difference between the Expenses (% of total expenses) of Moldova in 2006 and the Expenses (% of total expenses) of Sweden in 2009?
Provide a short and direct response. -2.33. What is the difference between the Expenses (% of total expenses) in Benin in 2007 and the Expenses (% of total expenses) in Congo (Democratic) in 2008?
Offer a very short reply. -16.3. What is the difference between the Expenses (% of total expenses) of Benin in 2007 and the Expenses (% of total expenses) of Moldova in 2008?
Your answer should be very brief. -3.2. What is the difference between the Expenses (% of total expenses) in Benin in 2007 and the Expenses (% of total expenses) in Sweden in 2008?
Provide a succinct answer. -7.71. What is the difference between the Expenses (% of total expenses) in Congo (Democratic) in 2007 and the Expenses (% of total expenses) in Moldova in 2008?
Provide a short and direct response. 19.92. What is the difference between the Expenses (% of total expenses) in Congo (Democratic) in 2007 and the Expenses (% of total expenses) in Sweden in 2008?
Your response must be concise. 15.41. What is the difference between the Expenses (% of total expenses) in Moldova in 2007 and the Expenses (% of total expenses) in Sweden in 2008?
Keep it short and to the point. -3.46. What is the difference between the Expenses (% of total expenses) of Benin in 2007 and the Expenses (% of total expenses) of Congo (Democratic) in 2009?
Your response must be concise. -5.16. What is the difference between the Expenses (% of total expenses) of Benin in 2007 and the Expenses (% of total expenses) of Moldova in 2009?
Offer a very short reply. -3.3. What is the difference between the Expenses (% of total expenses) in Benin in 2007 and the Expenses (% of total expenses) in Sweden in 2009?
Provide a succinct answer. -5.82. What is the difference between the Expenses (% of total expenses) in Congo (Democratic) in 2007 and the Expenses (% of total expenses) in Moldova in 2009?
Offer a very short reply. 19.81. What is the difference between the Expenses (% of total expenses) in Congo (Democratic) in 2007 and the Expenses (% of total expenses) in Sweden in 2009?
Your answer should be very brief. 17.3. What is the difference between the Expenses (% of total expenses) of Moldova in 2007 and the Expenses (% of total expenses) of Sweden in 2009?
Provide a succinct answer. -1.57. What is the difference between the Expenses (% of total expenses) in Benin in 2008 and the Expenses (% of total expenses) in Congo (Democratic) in 2009?
Provide a short and direct response. -5.51. What is the difference between the Expenses (% of total expenses) in Benin in 2008 and the Expenses (% of total expenses) in Moldova in 2009?
Your response must be concise. -3.64. What is the difference between the Expenses (% of total expenses) of Benin in 2008 and the Expenses (% of total expenses) of Sweden in 2009?
Ensure brevity in your answer.  -6.16. What is the difference between the Expenses (% of total expenses) of Congo (Democratic) in 2008 and the Expenses (% of total expenses) of Moldova in 2009?
Your answer should be very brief. 13. What is the difference between the Expenses (% of total expenses) in Congo (Democratic) in 2008 and the Expenses (% of total expenses) in Sweden in 2009?
Ensure brevity in your answer.  10.48. What is the difference between the Expenses (% of total expenses) of Moldova in 2008 and the Expenses (% of total expenses) of Sweden in 2009?
Make the answer very short. -2.62. What is the average Expenses (% of total expenses) of Benin per year?
Keep it short and to the point. 12.92. What is the average Expenses (% of total expenses) in Congo (Democratic) per year?
Keep it short and to the point. 26.33. What is the average Expenses (% of total expenses) of Moldova per year?
Give a very brief answer. 6.81. What is the average Expenses (% of total expenses) in Sweden per year?
Your answer should be compact. 6.98. In the year 2001, what is the difference between the Expenses (% of total expenses) in Benin and Expenses (% of total expenses) in Congo (Democratic)?
Your answer should be compact. -27.47. In the year 2001, what is the difference between the Expenses (% of total expenses) of Benin and Expenses (% of total expenses) of Moldova?
Your answer should be very brief. 20.63. In the year 2001, what is the difference between the Expenses (% of total expenses) of Benin and Expenses (% of total expenses) of Sweden?
Provide a short and direct response. 15.07. In the year 2001, what is the difference between the Expenses (% of total expenses) in Congo (Democratic) and Expenses (% of total expenses) in Moldova?
Make the answer very short. 48.1. In the year 2001, what is the difference between the Expenses (% of total expenses) in Congo (Democratic) and Expenses (% of total expenses) in Sweden?
Give a very brief answer. 42.54. In the year 2001, what is the difference between the Expenses (% of total expenses) in Moldova and Expenses (% of total expenses) in Sweden?
Give a very brief answer. -5.56. In the year 2003, what is the difference between the Expenses (% of total expenses) in Benin and Expenses (% of total expenses) in Congo (Democratic)?
Your answer should be very brief. 3.32. In the year 2003, what is the difference between the Expenses (% of total expenses) in Benin and Expenses (% of total expenses) in Moldova?
Your answer should be very brief. 14.86. In the year 2003, what is the difference between the Expenses (% of total expenses) in Benin and Expenses (% of total expenses) in Sweden?
Give a very brief answer. 18.36. In the year 2003, what is the difference between the Expenses (% of total expenses) of Congo (Democratic) and Expenses (% of total expenses) of Moldova?
Offer a terse response. 11.54. In the year 2003, what is the difference between the Expenses (% of total expenses) of Congo (Democratic) and Expenses (% of total expenses) of Sweden?
Your answer should be compact. 15.04. In the year 2003, what is the difference between the Expenses (% of total expenses) in Moldova and Expenses (% of total expenses) in Sweden?
Ensure brevity in your answer.  3.5. In the year 2004, what is the difference between the Expenses (% of total expenses) in Benin and Expenses (% of total expenses) in Congo (Democratic)?
Offer a terse response. -3.13. In the year 2004, what is the difference between the Expenses (% of total expenses) in Benin and Expenses (% of total expenses) in Moldova?
Make the answer very short. 13.42. In the year 2004, what is the difference between the Expenses (% of total expenses) in Benin and Expenses (% of total expenses) in Sweden?
Keep it short and to the point. 17.15. In the year 2004, what is the difference between the Expenses (% of total expenses) of Congo (Democratic) and Expenses (% of total expenses) of Moldova?
Keep it short and to the point. 16.56. In the year 2004, what is the difference between the Expenses (% of total expenses) of Congo (Democratic) and Expenses (% of total expenses) of Sweden?
Make the answer very short. 20.29. In the year 2004, what is the difference between the Expenses (% of total expenses) in Moldova and Expenses (% of total expenses) in Sweden?
Provide a short and direct response. 3.73. In the year 2005, what is the difference between the Expenses (% of total expenses) of Benin and Expenses (% of total expenses) of Congo (Democratic)?
Your answer should be compact. -7.96. In the year 2005, what is the difference between the Expenses (% of total expenses) of Benin and Expenses (% of total expenses) of Moldova?
Offer a very short reply. 14.94. In the year 2005, what is the difference between the Expenses (% of total expenses) in Benin and Expenses (% of total expenses) in Sweden?
Provide a succinct answer. 19.09. In the year 2005, what is the difference between the Expenses (% of total expenses) of Congo (Democratic) and Expenses (% of total expenses) of Moldova?
Keep it short and to the point. 22.9. In the year 2005, what is the difference between the Expenses (% of total expenses) in Congo (Democratic) and Expenses (% of total expenses) in Sweden?
Provide a short and direct response. 27.05. In the year 2005, what is the difference between the Expenses (% of total expenses) of Moldova and Expenses (% of total expenses) of Sweden?
Your answer should be very brief. 4.15. In the year 2006, what is the difference between the Expenses (% of total expenses) in Benin and Expenses (% of total expenses) in Congo (Democratic)?
Give a very brief answer. -26.97. In the year 2006, what is the difference between the Expenses (% of total expenses) in Benin and Expenses (% of total expenses) in Moldova?
Ensure brevity in your answer.  -3.74. In the year 2006, what is the difference between the Expenses (% of total expenses) of Benin and Expenses (% of total expenses) of Sweden?
Offer a very short reply. -4.15. In the year 2006, what is the difference between the Expenses (% of total expenses) in Congo (Democratic) and Expenses (% of total expenses) in Moldova?
Provide a succinct answer. 23.22. In the year 2006, what is the difference between the Expenses (% of total expenses) of Congo (Democratic) and Expenses (% of total expenses) of Sweden?
Your answer should be compact. 22.82. In the year 2006, what is the difference between the Expenses (% of total expenses) of Moldova and Expenses (% of total expenses) of Sweden?
Your answer should be compact. -0.41. In the year 2007, what is the difference between the Expenses (% of total expenses) of Benin and Expenses (% of total expenses) of Congo (Democratic)?
Provide a succinct answer. -23.12. In the year 2007, what is the difference between the Expenses (% of total expenses) of Benin and Expenses (% of total expenses) of Moldova?
Your answer should be compact. -4.25. In the year 2007, what is the difference between the Expenses (% of total expenses) of Benin and Expenses (% of total expenses) of Sweden?
Keep it short and to the point. -3.99. In the year 2007, what is the difference between the Expenses (% of total expenses) in Congo (Democratic) and Expenses (% of total expenses) in Moldova?
Make the answer very short. 18.86. In the year 2007, what is the difference between the Expenses (% of total expenses) in Congo (Democratic) and Expenses (% of total expenses) in Sweden?
Your response must be concise. 19.13. In the year 2007, what is the difference between the Expenses (% of total expenses) of Moldova and Expenses (% of total expenses) of Sweden?
Give a very brief answer. 0.27. In the year 2008, what is the difference between the Expenses (% of total expenses) in Benin and Expenses (% of total expenses) in Congo (Democratic)?
Your answer should be very brief. -16.65. In the year 2008, what is the difference between the Expenses (% of total expenses) of Benin and Expenses (% of total expenses) of Moldova?
Keep it short and to the point. -3.54. In the year 2008, what is the difference between the Expenses (% of total expenses) in Benin and Expenses (% of total expenses) in Sweden?
Your answer should be very brief. -8.05. In the year 2008, what is the difference between the Expenses (% of total expenses) in Congo (Democratic) and Expenses (% of total expenses) in Moldova?
Offer a very short reply. 13.11. In the year 2008, what is the difference between the Expenses (% of total expenses) of Congo (Democratic) and Expenses (% of total expenses) of Sweden?
Your answer should be compact. 8.6. In the year 2008, what is the difference between the Expenses (% of total expenses) in Moldova and Expenses (% of total expenses) in Sweden?
Make the answer very short. -4.51. In the year 2009, what is the difference between the Expenses (% of total expenses) of Benin and Expenses (% of total expenses) of Congo (Democratic)?
Your response must be concise. -5.34. In the year 2009, what is the difference between the Expenses (% of total expenses) of Benin and Expenses (% of total expenses) of Moldova?
Make the answer very short. -3.48. In the year 2009, what is the difference between the Expenses (% of total expenses) of Benin and Expenses (% of total expenses) of Sweden?
Give a very brief answer. -6. In the year 2009, what is the difference between the Expenses (% of total expenses) in Congo (Democratic) and Expenses (% of total expenses) in Moldova?
Ensure brevity in your answer.  1.86. In the year 2009, what is the difference between the Expenses (% of total expenses) in Congo (Democratic) and Expenses (% of total expenses) in Sweden?
Offer a terse response. -0.66. In the year 2009, what is the difference between the Expenses (% of total expenses) in Moldova and Expenses (% of total expenses) in Sweden?
Provide a succinct answer. -2.52. What is the ratio of the Expenses (% of total expenses) in Benin in 2001 to that in 2003?
Provide a short and direct response. 0.84. What is the ratio of the Expenses (% of total expenses) in Congo (Democratic) in 2001 to that in 2003?
Offer a terse response. 2.26. What is the ratio of the Expenses (% of total expenses) in Moldova in 2001 to that in 2003?
Provide a succinct answer. 0.02. What is the ratio of the Expenses (% of total expenses) of Sweden in 2001 to that in 2003?
Keep it short and to the point. 0.91. What is the ratio of the Expenses (% of total expenses) in Benin in 2001 to that in 2004?
Ensure brevity in your answer.  0.9. What is the ratio of the Expenses (% of total expenses) of Congo (Democratic) in 2001 to that in 2004?
Keep it short and to the point. 1.83. What is the ratio of the Expenses (% of total expenses) of Moldova in 2001 to that in 2004?
Provide a short and direct response. 0.02. What is the ratio of the Expenses (% of total expenses) of Sweden in 2001 to that in 2004?
Your response must be concise. 0.94. What is the ratio of the Expenses (% of total expenses) in Benin in 2001 to that in 2005?
Make the answer very short. 0.8. What is the ratio of the Expenses (% of total expenses) in Congo (Democratic) in 2001 to that in 2005?
Ensure brevity in your answer.  1.43. What is the ratio of the Expenses (% of total expenses) of Moldova in 2001 to that in 2005?
Give a very brief answer. 0.01. What is the ratio of the Expenses (% of total expenses) in Sweden in 2001 to that in 2005?
Your answer should be very brief. 0.84. What is the ratio of the Expenses (% of total expenses) in Benin in 2001 to that in 2006?
Ensure brevity in your answer.  9.75. What is the ratio of the Expenses (% of total expenses) of Congo (Democratic) in 2001 to that in 2006?
Provide a short and direct response. 1.66. What is the ratio of the Expenses (% of total expenses) in Moldova in 2001 to that in 2006?
Your response must be concise. 0.03. What is the ratio of the Expenses (% of total expenses) of Sweden in 2001 to that in 2006?
Keep it short and to the point. 0.91. What is the ratio of the Expenses (% of total expenses) of Benin in 2001 to that in 2007?
Provide a succinct answer. 8.69. What is the ratio of the Expenses (% of total expenses) in Congo (Democratic) in 2001 to that in 2007?
Provide a succinct answer. 1.89. What is the ratio of the Expenses (% of total expenses) in Moldova in 2001 to that in 2007?
Offer a terse response. 0.02. What is the ratio of the Expenses (% of total expenses) of Sweden in 2001 to that in 2007?
Offer a very short reply. 0.9. What is the ratio of the Expenses (% of total expenses) in Benin in 2001 to that in 2008?
Offer a very short reply. 10.14. What is the ratio of the Expenses (% of total expenses) of Congo (Democratic) in 2001 to that in 2008?
Offer a terse response. 2.58. What is the ratio of the Expenses (% of total expenses) of Moldova in 2001 to that in 2008?
Your response must be concise. 0.03. What is the ratio of the Expenses (% of total expenses) in Sweden in 2001 to that in 2008?
Offer a very short reply. 0.57. What is the ratio of the Expenses (% of total expenses) of Benin in 2001 to that in 2009?
Your answer should be compact. 9.39. What is the ratio of the Expenses (% of total expenses) in Congo (Democratic) in 2001 to that in 2009?
Give a very brief answer. 6.39. What is the ratio of the Expenses (% of total expenses) in Moldova in 2001 to that in 2009?
Provide a short and direct response. 0.03. What is the ratio of the Expenses (% of total expenses) of Sweden in 2001 to that in 2009?
Your answer should be very brief. 0.7. What is the ratio of the Expenses (% of total expenses) of Benin in 2003 to that in 2004?
Provide a short and direct response. 1.06. What is the ratio of the Expenses (% of total expenses) of Congo (Democratic) in 2003 to that in 2004?
Make the answer very short. 0.81. What is the ratio of the Expenses (% of total expenses) of Sweden in 2003 to that in 2004?
Offer a very short reply. 1.04. What is the ratio of the Expenses (% of total expenses) in Benin in 2003 to that in 2005?
Offer a very short reply. 0.95. What is the ratio of the Expenses (% of total expenses) of Congo (Democratic) in 2003 to that in 2005?
Provide a succinct answer. 0.63. What is the ratio of the Expenses (% of total expenses) of Moldova in 2003 to that in 2005?
Offer a very short reply. 0.9. What is the ratio of the Expenses (% of total expenses) of Sweden in 2003 to that in 2005?
Your answer should be compact. 0.93. What is the ratio of the Expenses (% of total expenses) in Benin in 2003 to that in 2006?
Offer a terse response. 11.56. What is the ratio of the Expenses (% of total expenses) in Congo (Democratic) in 2003 to that in 2006?
Give a very brief answer. 0.73. What is the ratio of the Expenses (% of total expenses) in Moldova in 2003 to that in 2006?
Offer a very short reply. 1.67. What is the ratio of the Expenses (% of total expenses) in Benin in 2003 to that in 2007?
Your answer should be compact. 10.31. What is the ratio of the Expenses (% of total expenses) of Congo (Democratic) in 2003 to that in 2007?
Your answer should be compact. 0.84. What is the ratio of the Expenses (% of total expenses) in Moldova in 2003 to that in 2007?
Offer a very short reply. 1.47. What is the ratio of the Expenses (% of total expenses) of Sweden in 2003 to that in 2007?
Your answer should be compact. 0.99. What is the ratio of the Expenses (% of total expenses) of Benin in 2003 to that in 2008?
Your response must be concise. 12.03. What is the ratio of the Expenses (% of total expenses) in Congo (Democratic) in 2003 to that in 2008?
Your answer should be compact. 1.14. What is the ratio of the Expenses (% of total expenses) of Moldova in 2003 to that in 2008?
Provide a short and direct response. 1.75. What is the ratio of the Expenses (% of total expenses) in Sweden in 2003 to that in 2008?
Your answer should be compact. 0.62. What is the ratio of the Expenses (% of total expenses) of Benin in 2003 to that in 2009?
Keep it short and to the point. 11.14. What is the ratio of the Expenses (% of total expenses) of Congo (Democratic) in 2003 to that in 2009?
Make the answer very short. 2.82. What is the ratio of the Expenses (% of total expenses) of Moldova in 2003 to that in 2009?
Give a very brief answer. 1.72. What is the ratio of the Expenses (% of total expenses) in Sweden in 2003 to that in 2009?
Give a very brief answer. 0.77. What is the ratio of the Expenses (% of total expenses) in Benin in 2004 to that in 2005?
Provide a short and direct response. 0.9. What is the ratio of the Expenses (% of total expenses) of Congo (Democratic) in 2004 to that in 2005?
Offer a very short reply. 0.78. What is the ratio of the Expenses (% of total expenses) of Moldova in 2004 to that in 2005?
Your response must be concise. 0.9. What is the ratio of the Expenses (% of total expenses) in Sweden in 2004 to that in 2005?
Ensure brevity in your answer.  0.89. What is the ratio of the Expenses (% of total expenses) of Benin in 2004 to that in 2006?
Ensure brevity in your answer.  10.89. What is the ratio of the Expenses (% of total expenses) of Congo (Democratic) in 2004 to that in 2006?
Give a very brief answer. 0.91. What is the ratio of the Expenses (% of total expenses) in Moldova in 2004 to that in 2006?
Your answer should be compact. 1.67. What is the ratio of the Expenses (% of total expenses) of Sweden in 2004 to that in 2006?
Ensure brevity in your answer.  0.97. What is the ratio of the Expenses (% of total expenses) in Benin in 2004 to that in 2007?
Provide a short and direct response. 9.71. What is the ratio of the Expenses (% of total expenses) of Moldova in 2004 to that in 2007?
Make the answer very short. 1.47. What is the ratio of the Expenses (% of total expenses) in Sweden in 2004 to that in 2007?
Provide a succinct answer. 0.95. What is the ratio of the Expenses (% of total expenses) of Benin in 2004 to that in 2008?
Make the answer very short. 11.32. What is the ratio of the Expenses (% of total expenses) in Congo (Democratic) in 2004 to that in 2008?
Your answer should be compact. 1.41. What is the ratio of the Expenses (% of total expenses) of Moldova in 2004 to that in 2008?
Your answer should be very brief. 1.75. What is the ratio of the Expenses (% of total expenses) of Sweden in 2004 to that in 2008?
Your answer should be compact. 0.6. What is the ratio of the Expenses (% of total expenses) of Benin in 2004 to that in 2009?
Provide a short and direct response. 10.49. What is the ratio of the Expenses (% of total expenses) in Congo (Democratic) in 2004 to that in 2009?
Give a very brief answer. 3.49. What is the ratio of the Expenses (% of total expenses) of Moldova in 2004 to that in 2009?
Offer a terse response. 1.72. What is the ratio of the Expenses (% of total expenses) in Sweden in 2004 to that in 2009?
Ensure brevity in your answer.  0.74. What is the ratio of the Expenses (% of total expenses) of Benin in 2005 to that in 2006?
Your answer should be very brief. 12.14. What is the ratio of the Expenses (% of total expenses) of Congo (Democratic) in 2005 to that in 2006?
Make the answer very short. 1.16. What is the ratio of the Expenses (% of total expenses) in Moldova in 2005 to that in 2006?
Provide a succinct answer. 1.86. What is the ratio of the Expenses (% of total expenses) in Sweden in 2005 to that in 2006?
Keep it short and to the point. 1.08. What is the ratio of the Expenses (% of total expenses) in Benin in 2005 to that in 2007?
Provide a succinct answer. 10.82. What is the ratio of the Expenses (% of total expenses) in Congo (Democratic) in 2005 to that in 2007?
Your answer should be very brief. 1.33. What is the ratio of the Expenses (% of total expenses) in Moldova in 2005 to that in 2007?
Provide a succinct answer. 1.65. What is the ratio of the Expenses (% of total expenses) in Sweden in 2005 to that in 2007?
Give a very brief answer. 1.06. What is the ratio of the Expenses (% of total expenses) of Benin in 2005 to that in 2008?
Provide a succinct answer. 12.62. What is the ratio of the Expenses (% of total expenses) in Congo (Democratic) in 2005 to that in 2008?
Your answer should be very brief. 1.81. What is the ratio of the Expenses (% of total expenses) in Moldova in 2005 to that in 2008?
Keep it short and to the point. 1.96. What is the ratio of the Expenses (% of total expenses) in Sweden in 2005 to that in 2008?
Your answer should be very brief. 0.67. What is the ratio of the Expenses (% of total expenses) in Benin in 2005 to that in 2009?
Ensure brevity in your answer.  11.7. What is the ratio of the Expenses (% of total expenses) in Congo (Democratic) in 2005 to that in 2009?
Provide a succinct answer. 4.48. What is the ratio of the Expenses (% of total expenses) of Moldova in 2005 to that in 2009?
Keep it short and to the point. 1.92. What is the ratio of the Expenses (% of total expenses) of Sweden in 2005 to that in 2009?
Give a very brief answer. 0.83. What is the ratio of the Expenses (% of total expenses) of Benin in 2006 to that in 2007?
Ensure brevity in your answer.  0.89. What is the ratio of the Expenses (% of total expenses) in Congo (Democratic) in 2006 to that in 2007?
Give a very brief answer. 1.14. What is the ratio of the Expenses (% of total expenses) of Moldova in 2006 to that in 2007?
Provide a succinct answer. 0.88. What is the ratio of the Expenses (% of total expenses) in Sweden in 2006 to that in 2007?
Your answer should be compact. 0.99. What is the ratio of the Expenses (% of total expenses) in Benin in 2006 to that in 2008?
Provide a short and direct response. 1.04. What is the ratio of the Expenses (% of total expenses) of Congo (Democratic) in 2006 to that in 2008?
Provide a short and direct response. 1.56. What is the ratio of the Expenses (% of total expenses) of Moldova in 2006 to that in 2008?
Make the answer very short. 1.05. What is the ratio of the Expenses (% of total expenses) of Sweden in 2006 to that in 2008?
Offer a terse response. 0.62. What is the ratio of the Expenses (% of total expenses) of Benin in 2006 to that in 2009?
Offer a terse response. 0.96. What is the ratio of the Expenses (% of total expenses) in Congo (Democratic) in 2006 to that in 2009?
Your answer should be compact. 3.85. What is the ratio of the Expenses (% of total expenses) of Moldova in 2006 to that in 2009?
Offer a very short reply. 1.03. What is the ratio of the Expenses (% of total expenses) in Sweden in 2006 to that in 2009?
Your answer should be compact. 0.77. What is the ratio of the Expenses (% of total expenses) in Benin in 2007 to that in 2008?
Make the answer very short. 1.17. What is the ratio of the Expenses (% of total expenses) of Congo (Democratic) in 2007 to that in 2008?
Your answer should be very brief. 1.36. What is the ratio of the Expenses (% of total expenses) of Moldova in 2007 to that in 2008?
Offer a very short reply. 1.19. What is the ratio of the Expenses (% of total expenses) in Sweden in 2007 to that in 2008?
Provide a succinct answer. 0.63. What is the ratio of the Expenses (% of total expenses) of Benin in 2007 to that in 2009?
Make the answer very short. 1.08. What is the ratio of the Expenses (% of total expenses) in Congo (Democratic) in 2007 to that in 2009?
Offer a terse response. 3.38. What is the ratio of the Expenses (% of total expenses) of Moldova in 2007 to that in 2009?
Provide a short and direct response. 1.17. What is the ratio of the Expenses (% of total expenses) of Sweden in 2007 to that in 2009?
Your response must be concise. 0.78. What is the ratio of the Expenses (% of total expenses) of Benin in 2008 to that in 2009?
Offer a terse response. 0.93. What is the ratio of the Expenses (% of total expenses) in Congo (Democratic) in 2008 to that in 2009?
Give a very brief answer. 2.47. What is the ratio of the Expenses (% of total expenses) of Moldova in 2008 to that in 2009?
Offer a very short reply. 0.98. What is the ratio of the Expenses (% of total expenses) of Sweden in 2008 to that in 2009?
Offer a very short reply. 1.23. What is the difference between the highest and the second highest Expenses (% of total expenses) in Benin?
Offer a terse response. 1.22. What is the difference between the highest and the second highest Expenses (% of total expenses) in Congo (Democratic)?
Your response must be concise. 14.42. What is the difference between the highest and the second highest Expenses (% of total expenses) in Moldova?
Your response must be concise. 1.14. What is the difference between the highest and the second highest Expenses (% of total expenses) in Sweden?
Your answer should be very brief. 1.89. What is the difference between the highest and the lowest Expenses (% of total expenses) of Benin?
Ensure brevity in your answer.  23.83. What is the difference between the highest and the lowest Expenses (% of total expenses) of Congo (Democratic)?
Keep it short and to the point. 40.7. What is the difference between the highest and the lowest Expenses (% of total expenses) in Moldova?
Provide a succinct answer. 10.78. What is the difference between the highest and the lowest Expenses (% of total expenses) of Sweden?
Keep it short and to the point. 4.38. 